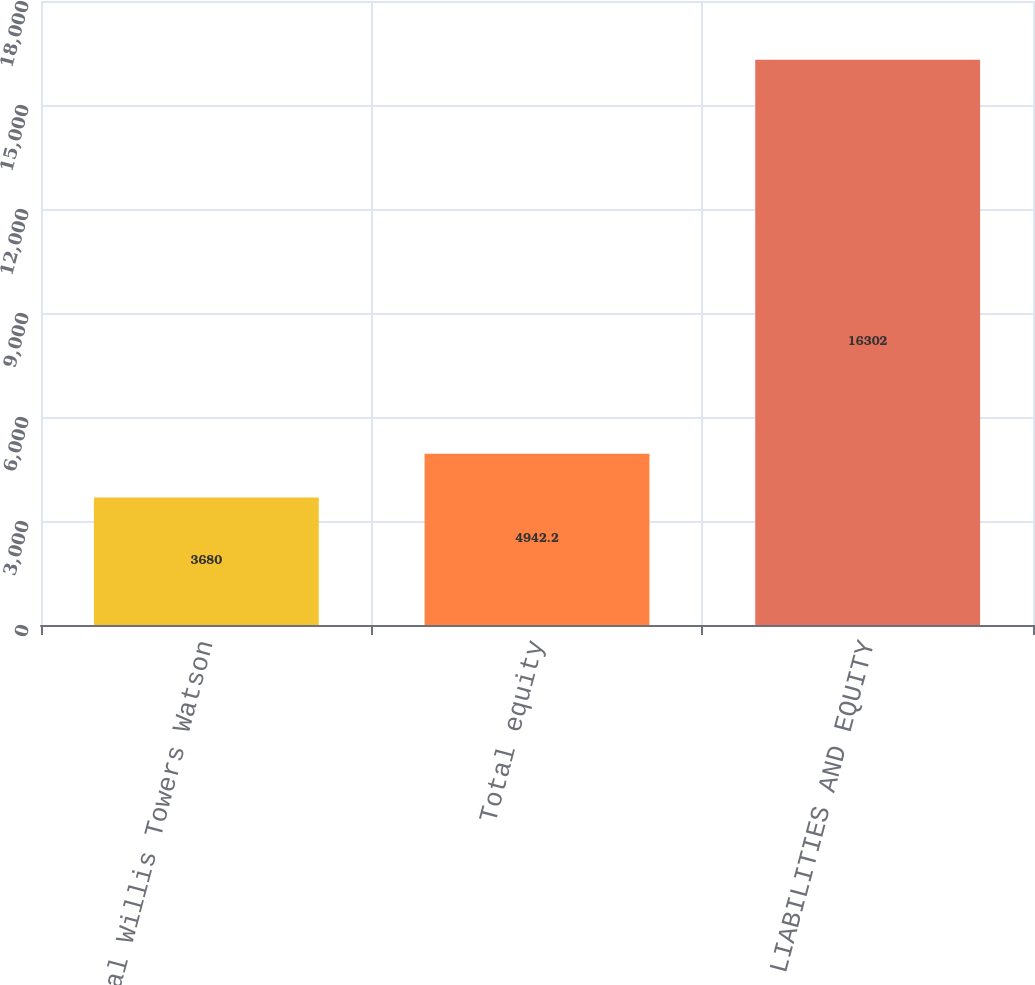<chart> <loc_0><loc_0><loc_500><loc_500><bar_chart><fcel>Total Willis Towers Watson<fcel>Total equity<fcel>TOTAL LIABILITIES AND EQUITY<nl><fcel>3680<fcel>4942.2<fcel>16302<nl></chart> 